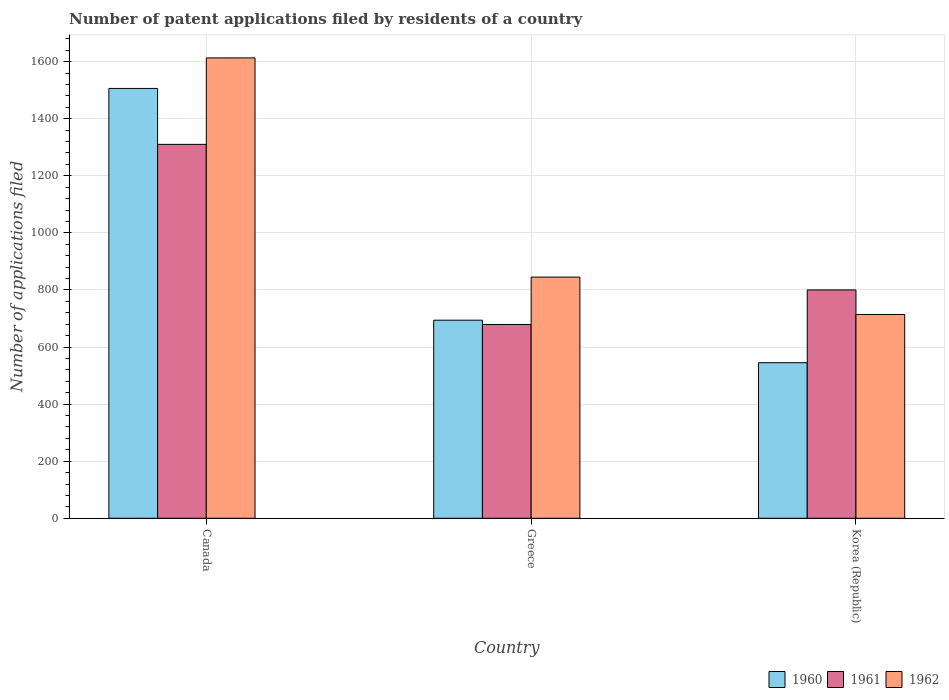Are the number of bars per tick equal to the number of legend labels?
Give a very brief answer. Yes. How many bars are there on the 1st tick from the left?
Ensure brevity in your answer.  3. What is the number of applications filed in 1960 in Korea (Republic)?
Ensure brevity in your answer.  545. Across all countries, what is the maximum number of applications filed in 1961?
Provide a succinct answer. 1310. Across all countries, what is the minimum number of applications filed in 1961?
Your answer should be very brief. 679. In which country was the number of applications filed in 1961 minimum?
Provide a short and direct response. Greece. What is the total number of applications filed in 1962 in the graph?
Ensure brevity in your answer.  3172. What is the difference between the number of applications filed in 1962 in Canada and that in Greece?
Make the answer very short. 768. What is the difference between the number of applications filed in 1961 in Canada and the number of applications filed in 1962 in Korea (Republic)?
Keep it short and to the point. 596. What is the average number of applications filed in 1961 per country?
Offer a terse response. 929.67. What is the difference between the number of applications filed of/in 1961 and number of applications filed of/in 1962 in Canada?
Offer a very short reply. -303. In how many countries, is the number of applications filed in 1961 greater than 720?
Offer a very short reply. 2. What is the ratio of the number of applications filed in 1962 in Canada to that in Korea (Republic)?
Provide a succinct answer. 2.26. Is the number of applications filed in 1962 in Greece less than that in Korea (Republic)?
Provide a succinct answer. No. What is the difference between the highest and the second highest number of applications filed in 1961?
Your answer should be compact. -510. What is the difference between the highest and the lowest number of applications filed in 1961?
Provide a short and direct response. 631. In how many countries, is the number of applications filed in 1961 greater than the average number of applications filed in 1961 taken over all countries?
Your answer should be very brief. 1. Is the sum of the number of applications filed in 1960 in Canada and Greece greater than the maximum number of applications filed in 1962 across all countries?
Your answer should be very brief. Yes. What does the 3rd bar from the left in Canada represents?
Offer a very short reply. 1962. How many countries are there in the graph?
Your answer should be very brief. 3. What is the difference between two consecutive major ticks on the Y-axis?
Ensure brevity in your answer.  200. Does the graph contain any zero values?
Keep it short and to the point. No. Where does the legend appear in the graph?
Ensure brevity in your answer.  Bottom right. How many legend labels are there?
Offer a very short reply. 3. How are the legend labels stacked?
Keep it short and to the point. Horizontal. What is the title of the graph?
Your response must be concise. Number of patent applications filed by residents of a country. What is the label or title of the Y-axis?
Offer a very short reply. Number of applications filed. What is the Number of applications filed of 1960 in Canada?
Make the answer very short. 1506. What is the Number of applications filed of 1961 in Canada?
Keep it short and to the point. 1310. What is the Number of applications filed in 1962 in Canada?
Provide a succinct answer. 1613. What is the Number of applications filed of 1960 in Greece?
Provide a succinct answer. 694. What is the Number of applications filed in 1961 in Greece?
Provide a short and direct response. 679. What is the Number of applications filed of 1962 in Greece?
Provide a succinct answer. 845. What is the Number of applications filed of 1960 in Korea (Republic)?
Make the answer very short. 545. What is the Number of applications filed of 1961 in Korea (Republic)?
Make the answer very short. 800. What is the Number of applications filed in 1962 in Korea (Republic)?
Provide a short and direct response. 714. Across all countries, what is the maximum Number of applications filed of 1960?
Your answer should be compact. 1506. Across all countries, what is the maximum Number of applications filed in 1961?
Your answer should be compact. 1310. Across all countries, what is the maximum Number of applications filed in 1962?
Provide a succinct answer. 1613. Across all countries, what is the minimum Number of applications filed in 1960?
Your answer should be very brief. 545. Across all countries, what is the minimum Number of applications filed in 1961?
Your answer should be compact. 679. Across all countries, what is the minimum Number of applications filed in 1962?
Provide a succinct answer. 714. What is the total Number of applications filed in 1960 in the graph?
Your response must be concise. 2745. What is the total Number of applications filed of 1961 in the graph?
Give a very brief answer. 2789. What is the total Number of applications filed in 1962 in the graph?
Ensure brevity in your answer.  3172. What is the difference between the Number of applications filed in 1960 in Canada and that in Greece?
Your answer should be very brief. 812. What is the difference between the Number of applications filed in 1961 in Canada and that in Greece?
Give a very brief answer. 631. What is the difference between the Number of applications filed of 1962 in Canada and that in Greece?
Offer a very short reply. 768. What is the difference between the Number of applications filed of 1960 in Canada and that in Korea (Republic)?
Keep it short and to the point. 961. What is the difference between the Number of applications filed in 1961 in Canada and that in Korea (Republic)?
Provide a short and direct response. 510. What is the difference between the Number of applications filed in 1962 in Canada and that in Korea (Republic)?
Keep it short and to the point. 899. What is the difference between the Number of applications filed of 1960 in Greece and that in Korea (Republic)?
Keep it short and to the point. 149. What is the difference between the Number of applications filed in 1961 in Greece and that in Korea (Republic)?
Give a very brief answer. -121. What is the difference between the Number of applications filed of 1962 in Greece and that in Korea (Republic)?
Offer a very short reply. 131. What is the difference between the Number of applications filed in 1960 in Canada and the Number of applications filed in 1961 in Greece?
Your response must be concise. 827. What is the difference between the Number of applications filed of 1960 in Canada and the Number of applications filed of 1962 in Greece?
Give a very brief answer. 661. What is the difference between the Number of applications filed of 1961 in Canada and the Number of applications filed of 1962 in Greece?
Ensure brevity in your answer.  465. What is the difference between the Number of applications filed in 1960 in Canada and the Number of applications filed in 1961 in Korea (Republic)?
Your answer should be compact. 706. What is the difference between the Number of applications filed in 1960 in Canada and the Number of applications filed in 1962 in Korea (Republic)?
Make the answer very short. 792. What is the difference between the Number of applications filed in 1961 in Canada and the Number of applications filed in 1962 in Korea (Republic)?
Make the answer very short. 596. What is the difference between the Number of applications filed of 1960 in Greece and the Number of applications filed of 1961 in Korea (Republic)?
Ensure brevity in your answer.  -106. What is the difference between the Number of applications filed of 1961 in Greece and the Number of applications filed of 1962 in Korea (Republic)?
Your answer should be very brief. -35. What is the average Number of applications filed of 1960 per country?
Ensure brevity in your answer.  915. What is the average Number of applications filed in 1961 per country?
Ensure brevity in your answer.  929.67. What is the average Number of applications filed of 1962 per country?
Offer a very short reply. 1057.33. What is the difference between the Number of applications filed in 1960 and Number of applications filed in 1961 in Canada?
Your answer should be compact. 196. What is the difference between the Number of applications filed in 1960 and Number of applications filed in 1962 in Canada?
Ensure brevity in your answer.  -107. What is the difference between the Number of applications filed in 1961 and Number of applications filed in 1962 in Canada?
Provide a short and direct response. -303. What is the difference between the Number of applications filed of 1960 and Number of applications filed of 1962 in Greece?
Offer a terse response. -151. What is the difference between the Number of applications filed in 1961 and Number of applications filed in 1962 in Greece?
Provide a short and direct response. -166. What is the difference between the Number of applications filed of 1960 and Number of applications filed of 1961 in Korea (Republic)?
Ensure brevity in your answer.  -255. What is the difference between the Number of applications filed in 1960 and Number of applications filed in 1962 in Korea (Republic)?
Your answer should be compact. -169. What is the ratio of the Number of applications filed in 1960 in Canada to that in Greece?
Ensure brevity in your answer.  2.17. What is the ratio of the Number of applications filed in 1961 in Canada to that in Greece?
Provide a short and direct response. 1.93. What is the ratio of the Number of applications filed in 1962 in Canada to that in Greece?
Make the answer very short. 1.91. What is the ratio of the Number of applications filed in 1960 in Canada to that in Korea (Republic)?
Give a very brief answer. 2.76. What is the ratio of the Number of applications filed in 1961 in Canada to that in Korea (Republic)?
Your answer should be very brief. 1.64. What is the ratio of the Number of applications filed of 1962 in Canada to that in Korea (Republic)?
Your answer should be compact. 2.26. What is the ratio of the Number of applications filed of 1960 in Greece to that in Korea (Republic)?
Give a very brief answer. 1.27. What is the ratio of the Number of applications filed of 1961 in Greece to that in Korea (Republic)?
Ensure brevity in your answer.  0.85. What is the ratio of the Number of applications filed of 1962 in Greece to that in Korea (Republic)?
Offer a terse response. 1.18. What is the difference between the highest and the second highest Number of applications filed in 1960?
Offer a terse response. 812. What is the difference between the highest and the second highest Number of applications filed in 1961?
Ensure brevity in your answer.  510. What is the difference between the highest and the second highest Number of applications filed in 1962?
Provide a succinct answer. 768. What is the difference between the highest and the lowest Number of applications filed of 1960?
Make the answer very short. 961. What is the difference between the highest and the lowest Number of applications filed in 1961?
Offer a terse response. 631. What is the difference between the highest and the lowest Number of applications filed in 1962?
Offer a terse response. 899. 